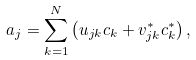<formula> <loc_0><loc_0><loc_500><loc_500>a _ { j } = \sum _ { k = 1 } ^ { N } \left ( u _ { j k } c _ { k } + v _ { j k } ^ { \ast } c _ { k } ^ { \ast } \right ) ,</formula> 